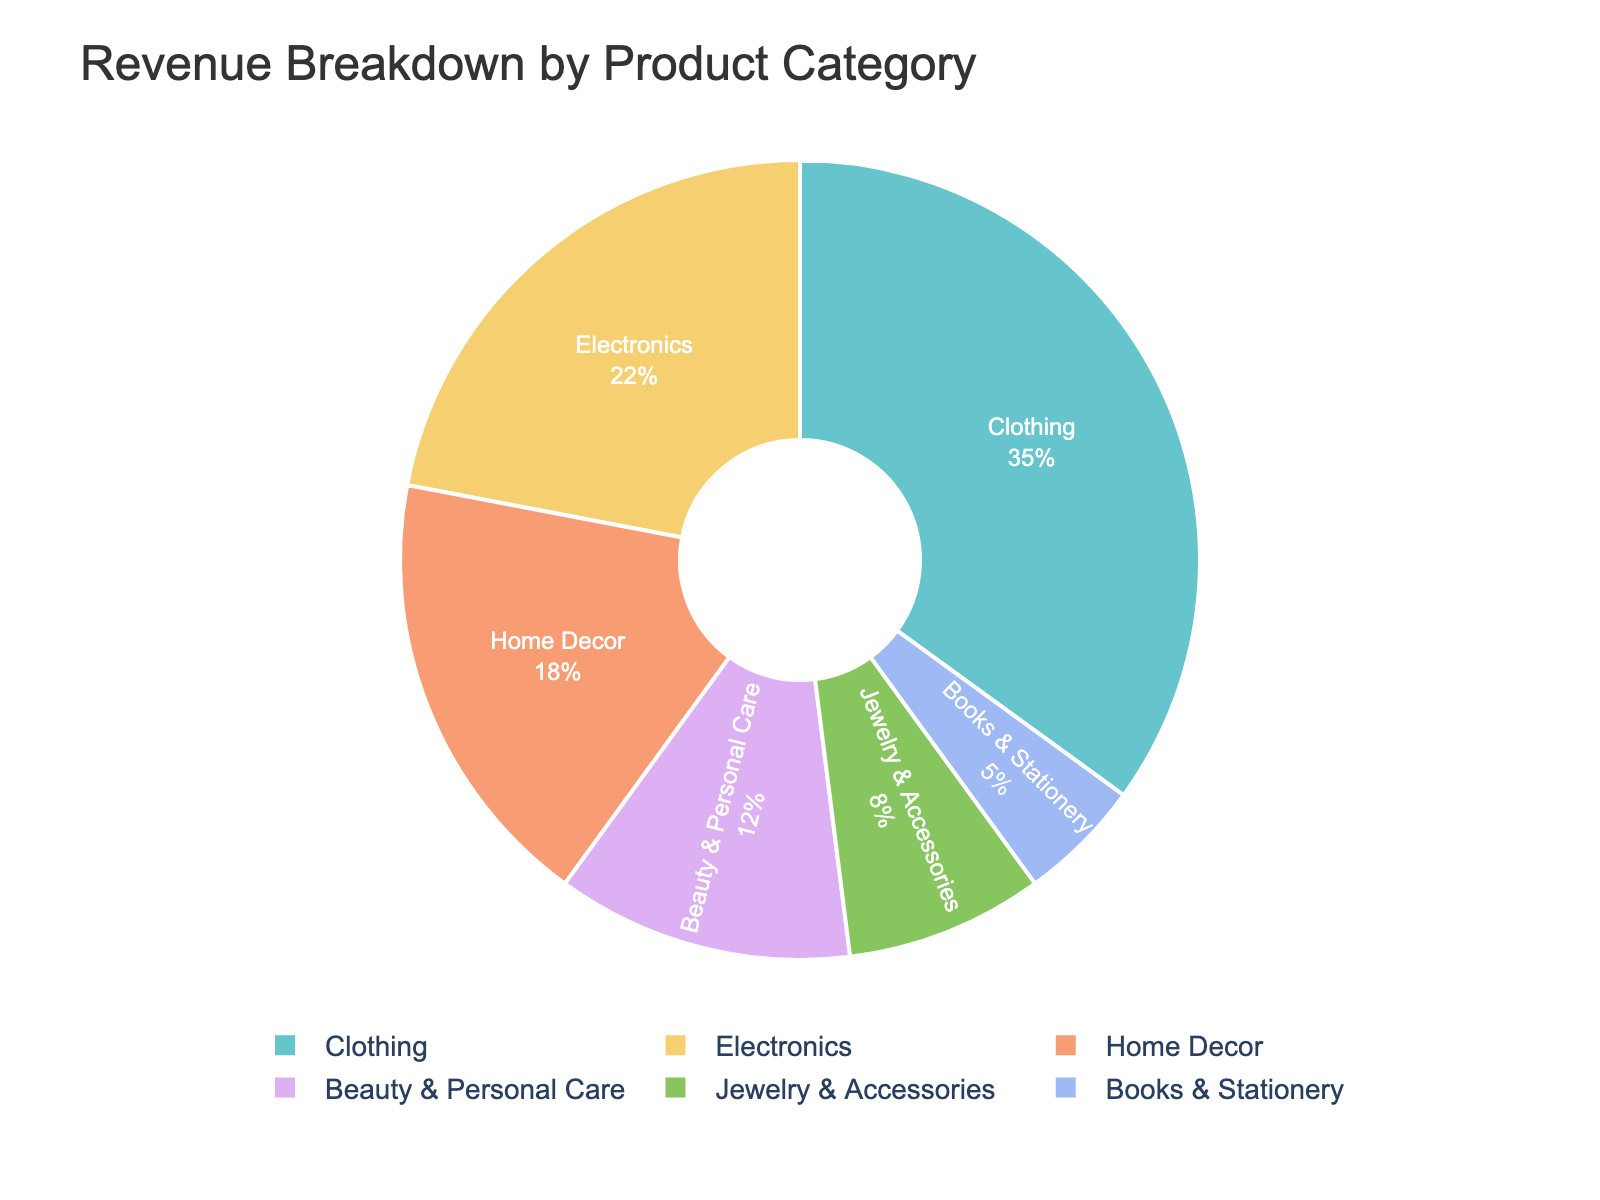What product category contributes the most to the total revenue? The 'Clothing' category has the largest segment in the pie chart, indicating it contributes the most to the total revenue.
Answer: Clothing Which product category contributes the least to the total revenue? The 'Books & Stationery' category has the smallest segment in the pie chart, indicating it contributes the least to the total revenue.
Answer: Books & Stationery How much more revenue does Clothing generate compared to Jewelry & Accessories? To find the difference in revenue percentages between Clothing and Jewelry & Accessories, subtract Jewelry & Accessories' percentage from Clothing's percentage: 35% - 8% = 27%.
Answer: 27% Are the combined revenues of Home Decor and Beauty & Personal Care greater than the revenue of Clothing? Combine Home Decor and Beauty & Personal Care percentages: 18% + 12% = 30%. Compare it to Clothing's 35%. Since 30% < 35%, their combined revenues are not greater.
Answer: No What is the combined revenue percentage of Electronics and Jewelry & Accessories? Sum the percentages for Electronics and Jewelry & Accessories: 22% + 8% = 30%.
Answer: 30% Which product categories together account for half of the total revenue? The categories 'Clothing' and 'Electronics' together account for 35% + 22% = 57%, which is more than half. Since no smaller combination exceeds 50%, they account for half the revenue.
Answer: Clothing, Electronics If the revenue from Beauty & Personal Care was increased by 3%, how would its new percentage compare with Home Decor? Increase Beauty & Personal Care by 3%: 12% + 3% = 15%. Compare it to Home Decor's 18%. Since 15% < 18%, it is still less than Home Decor.
Answer: Less What is the average revenue percentage of the top three product categories? Identify the top three categories: Clothing (35%), Electronics (22%), and Home Decor (18%). Average them: (35% + 22% + 18%) / 3 = 75% / 3 = 25%.
Answer: 25% 